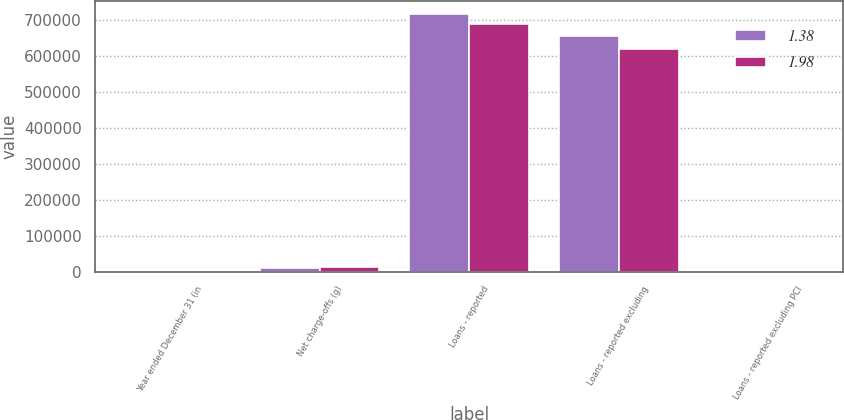Convert chart to OTSL. <chart><loc_0><loc_0><loc_500><loc_500><stacked_bar_chart><ecel><fcel>Year ended December 31 (in<fcel>Net charge-offs (g)<fcel>Loans - reported<fcel>Loans - reported excluding<fcel>Loans - reported excluding PCI<nl><fcel>1.38<fcel>2012<fcel>9063<fcel>717035<fcel>654454<fcel>1.38<nl><fcel>1.98<fcel>2011<fcel>12237<fcel>688181<fcel>619227<fcel>1.98<nl></chart> 